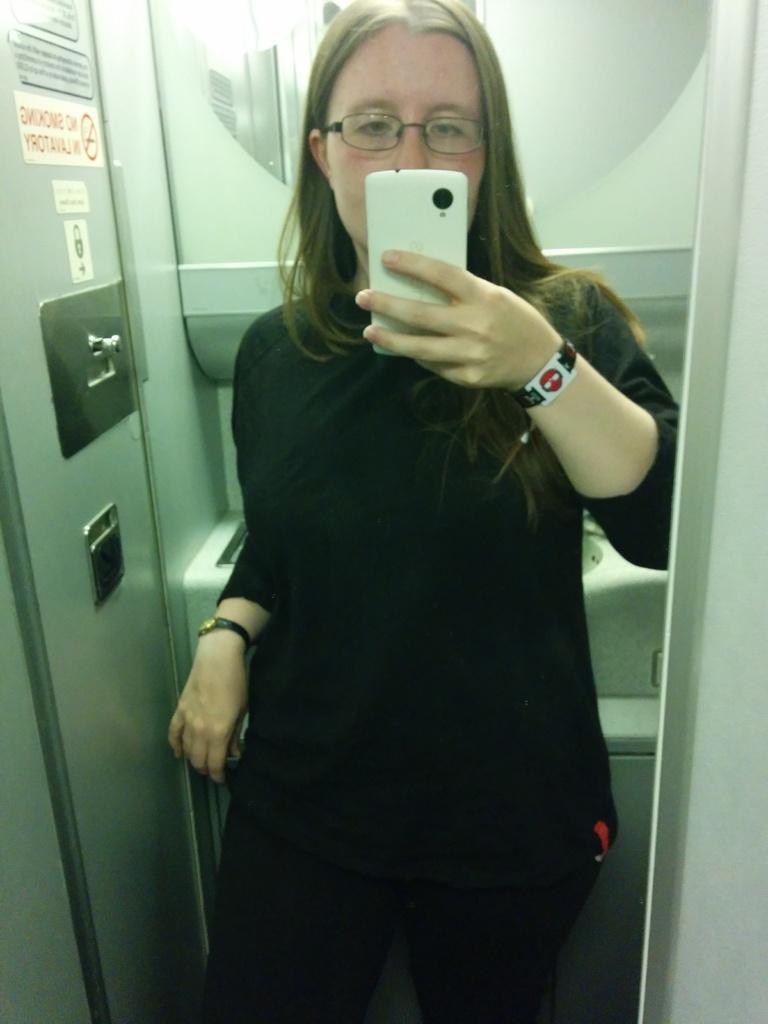How would you summarize this image in a sentence or two? In this picture we can see a woman and she is taking picture. 